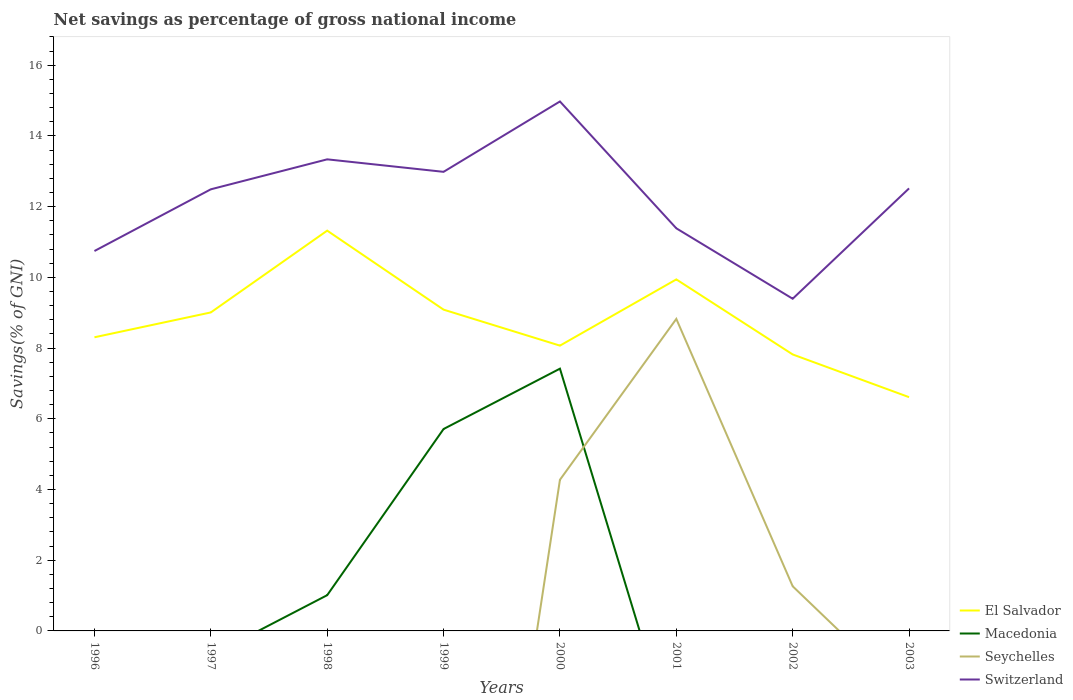Does the line corresponding to El Salvador intersect with the line corresponding to Seychelles?
Keep it short and to the point. No. Is the number of lines equal to the number of legend labels?
Your answer should be compact. No. What is the total total savings in El Salvador in the graph?
Your answer should be very brief. 0.24. What is the difference between the highest and the second highest total savings in Seychelles?
Ensure brevity in your answer.  8.82. How many lines are there?
Your response must be concise. 4. What is the difference between two consecutive major ticks on the Y-axis?
Provide a short and direct response. 2. Are the values on the major ticks of Y-axis written in scientific E-notation?
Make the answer very short. No. Does the graph contain any zero values?
Offer a very short reply. Yes. Does the graph contain grids?
Offer a terse response. No. How are the legend labels stacked?
Provide a succinct answer. Vertical. What is the title of the graph?
Offer a terse response. Net savings as percentage of gross national income. What is the label or title of the Y-axis?
Your response must be concise. Savings(% of GNI). What is the Savings(% of GNI) in El Salvador in 1996?
Provide a short and direct response. 8.3. What is the Savings(% of GNI) of Switzerland in 1996?
Your answer should be very brief. 10.74. What is the Savings(% of GNI) of El Salvador in 1997?
Ensure brevity in your answer.  9.01. What is the Savings(% of GNI) of Macedonia in 1997?
Provide a succinct answer. 0. What is the Savings(% of GNI) of Seychelles in 1997?
Give a very brief answer. 0. What is the Savings(% of GNI) of Switzerland in 1997?
Provide a short and direct response. 12.49. What is the Savings(% of GNI) of El Salvador in 1998?
Offer a terse response. 11.32. What is the Savings(% of GNI) of Macedonia in 1998?
Your response must be concise. 1.01. What is the Savings(% of GNI) of Switzerland in 1998?
Ensure brevity in your answer.  13.34. What is the Savings(% of GNI) in El Salvador in 1999?
Offer a terse response. 9.09. What is the Savings(% of GNI) in Macedonia in 1999?
Keep it short and to the point. 5.71. What is the Savings(% of GNI) in Seychelles in 1999?
Make the answer very short. 0. What is the Savings(% of GNI) of Switzerland in 1999?
Offer a very short reply. 12.98. What is the Savings(% of GNI) of El Salvador in 2000?
Your response must be concise. 8.07. What is the Savings(% of GNI) of Macedonia in 2000?
Keep it short and to the point. 7.42. What is the Savings(% of GNI) in Seychelles in 2000?
Keep it short and to the point. 4.27. What is the Savings(% of GNI) of Switzerland in 2000?
Your response must be concise. 14.97. What is the Savings(% of GNI) of El Salvador in 2001?
Give a very brief answer. 9.94. What is the Savings(% of GNI) in Macedonia in 2001?
Your answer should be very brief. 0. What is the Savings(% of GNI) in Seychelles in 2001?
Offer a terse response. 8.82. What is the Savings(% of GNI) of Switzerland in 2001?
Your response must be concise. 11.39. What is the Savings(% of GNI) in El Salvador in 2002?
Your answer should be compact. 7.82. What is the Savings(% of GNI) in Macedonia in 2002?
Your answer should be very brief. 0. What is the Savings(% of GNI) of Seychelles in 2002?
Give a very brief answer. 1.26. What is the Savings(% of GNI) in Switzerland in 2002?
Provide a short and direct response. 9.39. What is the Savings(% of GNI) of El Salvador in 2003?
Provide a short and direct response. 6.61. What is the Savings(% of GNI) of Macedonia in 2003?
Offer a very short reply. 0. What is the Savings(% of GNI) of Switzerland in 2003?
Your answer should be very brief. 12.51. Across all years, what is the maximum Savings(% of GNI) of El Salvador?
Make the answer very short. 11.32. Across all years, what is the maximum Savings(% of GNI) of Macedonia?
Your answer should be very brief. 7.42. Across all years, what is the maximum Savings(% of GNI) in Seychelles?
Keep it short and to the point. 8.82. Across all years, what is the maximum Savings(% of GNI) in Switzerland?
Your answer should be very brief. 14.97. Across all years, what is the minimum Savings(% of GNI) of El Salvador?
Give a very brief answer. 6.61. Across all years, what is the minimum Savings(% of GNI) in Macedonia?
Provide a succinct answer. 0. Across all years, what is the minimum Savings(% of GNI) in Switzerland?
Give a very brief answer. 9.39. What is the total Savings(% of GNI) in El Salvador in the graph?
Offer a terse response. 70.16. What is the total Savings(% of GNI) of Macedonia in the graph?
Offer a terse response. 14.14. What is the total Savings(% of GNI) of Seychelles in the graph?
Ensure brevity in your answer.  14.36. What is the total Savings(% of GNI) in Switzerland in the graph?
Provide a succinct answer. 97.82. What is the difference between the Savings(% of GNI) of El Salvador in 1996 and that in 1997?
Your answer should be compact. -0.7. What is the difference between the Savings(% of GNI) of Switzerland in 1996 and that in 1997?
Provide a succinct answer. -1.75. What is the difference between the Savings(% of GNI) of El Salvador in 1996 and that in 1998?
Offer a terse response. -3.02. What is the difference between the Savings(% of GNI) of Switzerland in 1996 and that in 1998?
Make the answer very short. -2.59. What is the difference between the Savings(% of GNI) of El Salvador in 1996 and that in 1999?
Your answer should be very brief. -0.78. What is the difference between the Savings(% of GNI) in Switzerland in 1996 and that in 1999?
Provide a short and direct response. -2.24. What is the difference between the Savings(% of GNI) in El Salvador in 1996 and that in 2000?
Offer a very short reply. 0.24. What is the difference between the Savings(% of GNI) in Switzerland in 1996 and that in 2000?
Provide a succinct answer. -4.23. What is the difference between the Savings(% of GNI) of El Salvador in 1996 and that in 2001?
Your answer should be very brief. -1.64. What is the difference between the Savings(% of GNI) of Switzerland in 1996 and that in 2001?
Keep it short and to the point. -0.64. What is the difference between the Savings(% of GNI) in El Salvador in 1996 and that in 2002?
Your response must be concise. 0.49. What is the difference between the Savings(% of GNI) of Switzerland in 1996 and that in 2002?
Your answer should be compact. 1.35. What is the difference between the Savings(% of GNI) of El Salvador in 1996 and that in 2003?
Your response must be concise. 1.69. What is the difference between the Savings(% of GNI) in Switzerland in 1996 and that in 2003?
Ensure brevity in your answer.  -1.77. What is the difference between the Savings(% of GNI) of El Salvador in 1997 and that in 1998?
Make the answer very short. -2.31. What is the difference between the Savings(% of GNI) of Switzerland in 1997 and that in 1998?
Your answer should be very brief. -0.85. What is the difference between the Savings(% of GNI) in El Salvador in 1997 and that in 1999?
Keep it short and to the point. -0.08. What is the difference between the Savings(% of GNI) in Switzerland in 1997 and that in 1999?
Your answer should be very brief. -0.49. What is the difference between the Savings(% of GNI) of El Salvador in 1997 and that in 2000?
Ensure brevity in your answer.  0.94. What is the difference between the Savings(% of GNI) in Switzerland in 1997 and that in 2000?
Your answer should be compact. -2.48. What is the difference between the Savings(% of GNI) of El Salvador in 1997 and that in 2001?
Make the answer very short. -0.93. What is the difference between the Savings(% of GNI) of Switzerland in 1997 and that in 2001?
Your answer should be very brief. 1.1. What is the difference between the Savings(% of GNI) in El Salvador in 1997 and that in 2002?
Offer a very short reply. 1.19. What is the difference between the Savings(% of GNI) of Switzerland in 1997 and that in 2002?
Keep it short and to the point. 3.09. What is the difference between the Savings(% of GNI) of El Salvador in 1997 and that in 2003?
Give a very brief answer. 2.4. What is the difference between the Savings(% of GNI) in Switzerland in 1997 and that in 2003?
Your answer should be very brief. -0.03. What is the difference between the Savings(% of GNI) in El Salvador in 1998 and that in 1999?
Offer a very short reply. 2.23. What is the difference between the Savings(% of GNI) in Macedonia in 1998 and that in 1999?
Your response must be concise. -4.7. What is the difference between the Savings(% of GNI) in Switzerland in 1998 and that in 1999?
Give a very brief answer. 0.35. What is the difference between the Savings(% of GNI) of El Salvador in 1998 and that in 2000?
Provide a short and direct response. 3.25. What is the difference between the Savings(% of GNI) in Macedonia in 1998 and that in 2000?
Ensure brevity in your answer.  -6.41. What is the difference between the Savings(% of GNI) of Switzerland in 1998 and that in 2000?
Offer a very short reply. -1.64. What is the difference between the Savings(% of GNI) of El Salvador in 1998 and that in 2001?
Give a very brief answer. 1.38. What is the difference between the Savings(% of GNI) in Switzerland in 1998 and that in 2001?
Your answer should be compact. 1.95. What is the difference between the Savings(% of GNI) in El Salvador in 1998 and that in 2002?
Offer a very short reply. 3.5. What is the difference between the Savings(% of GNI) in Switzerland in 1998 and that in 2002?
Ensure brevity in your answer.  3.94. What is the difference between the Savings(% of GNI) in El Salvador in 1998 and that in 2003?
Make the answer very short. 4.71. What is the difference between the Savings(% of GNI) of Switzerland in 1998 and that in 2003?
Your answer should be very brief. 0.82. What is the difference between the Savings(% of GNI) in El Salvador in 1999 and that in 2000?
Keep it short and to the point. 1.02. What is the difference between the Savings(% of GNI) in Macedonia in 1999 and that in 2000?
Your answer should be compact. -1.71. What is the difference between the Savings(% of GNI) in Switzerland in 1999 and that in 2000?
Offer a very short reply. -1.99. What is the difference between the Savings(% of GNI) in El Salvador in 1999 and that in 2001?
Provide a succinct answer. -0.86. What is the difference between the Savings(% of GNI) in Switzerland in 1999 and that in 2001?
Ensure brevity in your answer.  1.6. What is the difference between the Savings(% of GNI) of El Salvador in 1999 and that in 2002?
Offer a terse response. 1.27. What is the difference between the Savings(% of GNI) of Switzerland in 1999 and that in 2002?
Provide a succinct answer. 3.59. What is the difference between the Savings(% of GNI) in El Salvador in 1999 and that in 2003?
Provide a succinct answer. 2.48. What is the difference between the Savings(% of GNI) of Switzerland in 1999 and that in 2003?
Keep it short and to the point. 0.47. What is the difference between the Savings(% of GNI) in El Salvador in 2000 and that in 2001?
Give a very brief answer. -1.87. What is the difference between the Savings(% of GNI) in Seychelles in 2000 and that in 2001?
Offer a very short reply. -4.55. What is the difference between the Savings(% of GNI) in Switzerland in 2000 and that in 2001?
Offer a very short reply. 3.59. What is the difference between the Savings(% of GNI) of El Salvador in 2000 and that in 2002?
Your answer should be compact. 0.25. What is the difference between the Savings(% of GNI) of Seychelles in 2000 and that in 2002?
Your answer should be very brief. 3.01. What is the difference between the Savings(% of GNI) of Switzerland in 2000 and that in 2002?
Give a very brief answer. 5.58. What is the difference between the Savings(% of GNI) of El Salvador in 2000 and that in 2003?
Give a very brief answer. 1.46. What is the difference between the Savings(% of GNI) of Switzerland in 2000 and that in 2003?
Give a very brief answer. 2.46. What is the difference between the Savings(% of GNI) of El Salvador in 2001 and that in 2002?
Your answer should be compact. 2.12. What is the difference between the Savings(% of GNI) in Seychelles in 2001 and that in 2002?
Offer a terse response. 7.56. What is the difference between the Savings(% of GNI) in Switzerland in 2001 and that in 2002?
Your response must be concise. 1.99. What is the difference between the Savings(% of GNI) of El Salvador in 2001 and that in 2003?
Ensure brevity in your answer.  3.33. What is the difference between the Savings(% of GNI) of Switzerland in 2001 and that in 2003?
Provide a short and direct response. -1.13. What is the difference between the Savings(% of GNI) of El Salvador in 2002 and that in 2003?
Give a very brief answer. 1.21. What is the difference between the Savings(% of GNI) in Switzerland in 2002 and that in 2003?
Offer a very short reply. -3.12. What is the difference between the Savings(% of GNI) in El Salvador in 1996 and the Savings(% of GNI) in Switzerland in 1997?
Ensure brevity in your answer.  -4.18. What is the difference between the Savings(% of GNI) of El Salvador in 1996 and the Savings(% of GNI) of Macedonia in 1998?
Provide a succinct answer. 7.29. What is the difference between the Savings(% of GNI) in El Salvador in 1996 and the Savings(% of GNI) in Switzerland in 1998?
Make the answer very short. -5.03. What is the difference between the Savings(% of GNI) of El Salvador in 1996 and the Savings(% of GNI) of Macedonia in 1999?
Your answer should be compact. 2.59. What is the difference between the Savings(% of GNI) in El Salvador in 1996 and the Savings(% of GNI) in Switzerland in 1999?
Make the answer very short. -4.68. What is the difference between the Savings(% of GNI) of El Salvador in 1996 and the Savings(% of GNI) of Macedonia in 2000?
Offer a terse response. 0.89. What is the difference between the Savings(% of GNI) of El Salvador in 1996 and the Savings(% of GNI) of Seychelles in 2000?
Keep it short and to the point. 4.03. What is the difference between the Savings(% of GNI) in El Salvador in 1996 and the Savings(% of GNI) in Switzerland in 2000?
Ensure brevity in your answer.  -6.67. What is the difference between the Savings(% of GNI) in El Salvador in 1996 and the Savings(% of GNI) in Seychelles in 2001?
Your answer should be very brief. -0.52. What is the difference between the Savings(% of GNI) of El Salvador in 1996 and the Savings(% of GNI) of Switzerland in 2001?
Your response must be concise. -3.08. What is the difference between the Savings(% of GNI) in El Salvador in 1996 and the Savings(% of GNI) in Seychelles in 2002?
Your answer should be very brief. 7.04. What is the difference between the Savings(% of GNI) of El Salvador in 1996 and the Savings(% of GNI) of Switzerland in 2002?
Offer a very short reply. -1.09. What is the difference between the Savings(% of GNI) in El Salvador in 1996 and the Savings(% of GNI) in Switzerland in 2003?
Your answer should be very brief. -4.21. What is the difference between the Savings(% of GNI) of El Salvador in 1997 and the Savings(% of GNI) of Macedonia in 1998?
Provide a succinct answer. 8. What is the difference between the Savings(% of GNI) of El Salvador in 1997 and the Savings(% of GNI) of Switzerland in 1998?
Your answer should be very brief. -4.33. What is the difference between the Savings(% of GNI) in El Salvador in 1997 and the Savings(% of GNI) in Macedonia in 1999?
Provide a succinct answer. 3.3. What is the difference between the Savings(% of GNI) of El Salvador in 1997 and the Savings(% of GNI) of Switzerland in 1999?
Your response must be concise. -3.98. What is the difference between the Savings(% of GNI) of El Salvador in 1997 and the Savings(% of GNI) of Macedonia in 2000?
Ensure brevity in your answer.  1.59. What is the difference between the Savings(% of GNI) in El Salvador in 1997 and the Savings(% of GNI) in Seychelles in 2000?
Ensure brevity in your answer.  4.73. What is the difference between the Savings(% of GNI) of El Salvador in 1997 and the Savings(% of GNI) of Switzerland in 2000?
Your response must be concise. -5.97. What is the difference between the Savings(% of GNI) in El Salvador in 1997 and the Savings(% of GNI) in Seychelles in 2001?
Your answer should be very brief. 0.18. What is the difference between the Savings(% of GNI) in El Salvador in 1997 and the Savings(% of GNI) in Switzerland in 2001?
Your answer should be compact. -2.38. What is the difference between the Savings(% of GNI) in El Salvador in 1997 and the Savings(% of GNI) in Seychelles in 2002?
Give a very brief answer. 7.74. What is the difference between the Savings(% of GNI) of El Salvador in 1997 and the Savings(% of GNI) of Switzerland in 2002?
Offer a very short reply. -0.39. What is the difference between the Savings(% of GNI) of El Salvador in 1997 and the Savings(% of GNI) of Switzerland in 2003?
Your answer should be very brief. -3.51. What is the difference between the Savings(% of GNI) in El Salvador in 1998 and the Savings(% of GNI) in Macedonia in 1999?
Offer a very short reply. 5.61. What is the difference between the Savings(% of GNI) in El Salvador in 1998 and the Savings(% of GNI) in Switzerland in 1999?
Your answer should be compact. -1.66. What is the difference between the Savings(% of GNI) of Macedonia in 1998 and the Savings(% of GNI) of Switzerland in 1999?
Offer a very short reply. -11.97. What is the difference between the Savings(% of GNI) in El Salvador in 1998 and the Savings(% of GNI) in Macedonia in 2000?
Keep it short and to the point. 3.9. What is the difference between the Savings(% of GNI) in El Salvador in 1998 and the Savings(% of GNI) in Seychelles in 2000?
Offer a very short reply. 7.05. What is the difference between the Savings(% of GNI) of El Salvador in 1998 and the Savings(% of GNI) of Switzerland in 2000?
Offer a very short reply. -3.65. What is the difference between the Savings(% of GNI) in Macedonia in 1998 and the Savings(% of GNI) in Seychelles in 2000?
Offer a terse response. -3.26. What is the difference between the Savings(% of GNI) in Macedonia in 1998 and the Savings(% of GNI) in Switzerland in 2000?
Your answer should be very brief. -13.96. What is the difference between the Savings(% of GNI) of El Salvador in 1998 and the Savings(% of GNI) of Seychelles in 2001?
Your response must be concise. 2.5. What is the difference between the Savings(% of GNI) of El Salvador in 1998 and the Savings(% of GNI) of Switzerland in 2001?
Your response must be concise. -0.07. What is the difference between the Savings(% of GNI) in Macedonia in 1998 and the Savings(% of GNI) in Seychelles in 2001?
Give a very brief answer. -7.81. What is the difference between the Savings(% of GNI) in Macedonia in 1998 and the Savings(% of GNI) in Switzerland in 2001?
Keep it short and to the point. -10.37. What is the difference between the Savings(% of GNI) in El Salvador in 1998 and the Savings(% of GNI) in Seychelles in 2002?
Provide a succinct answer. 10.06. What is the difference between the Savings(% of GNI) of El Salvador in 1998 and the Savings(% of GNI) of Switzerland in 2002?
Ensure brevity in your answer.  1.93. What is the difference between the Savings(% of GNI) in Macedonia in 1998 and the Savings(% of GNI) in Seychelles in 2002?
Keep it short and to the point. -0.25. What is the difference between the Savings(% of GNI) of Macedonia in 1998 and the Savings(% of GNI) of Switzerland in 2002?
Ensure brevity in your answer.  -8.38. What is the difference between the Savings(% of GNI) of El Salvador in 1998 and the Savings(% of GNI) of Switzerland in 2003?
Your answer should be compact. -1.19. What is the difference between the Savings(% of GNI) in Macedonia in 1998 and the Savings(% of GNI) in Switzerland in 2003?
Your response must be concise. -11.5. What is the difference between the Savings(% of GNI) of El Salvador in 1999 and the Savings(% of GNI) of Macedonia in 2000?
Offer a terse response. 1.67. What is the difference between the Savings(% of GNI) of El Salvador in 1999 and the Savings(% of GNI) of Seychelles in 2000?
Your response must be concise. 4.81. What is the difference between the Savings(% of GNI) of El Salvador in 1999 and the Savings(% of GNI) of Switzerland in 2000?
Offer a terse response. -5.89. What is the difference between the Savings(% of GNI) of Macedonia in 1999 and the Savings(% of GNI) of Seychelles in 2000?
Your answer should be very brief. 1.44. What is the difference between the Savings(% of GNI) of Macedonia in 1999 and the Savings(% of GNI) of Switzerland in 2000?
Your response must be concise. -9.26. What is the difference between the Savings(% of GNI) of El Salvador in 1999 and the Savings(% of GNI) of Seychelles in 2001?
Keep it short and to the point. 0.26. What is the difference between the Savings(% of GNI) in El Salvador in 1999 and the Savings(% of GNI) in Switzerland in 2001?
Ensure brevity in your answer.  -2.3. What is the difference between the Savings(% of GNI) in Macedonia in 1999 and the Savings(% of GNI) in Seychelles in 2001?
Provide a succinct answer. -3.11. What is the difference between the Savings(% of GNI) in Macedonia in 1999 and the Savings(% of GNI) in Switzerland in 2001?
Provide a succinct answer. -5.68. What is the difference between the Savings(% of GNI) of El Salvador in 1999 and the Savings(% of GNI) of Seychelles in 2002?
Give a very brief answer. 7.82. What is the difference between the Savings(% of GNI) in El Salvador in 1999 and the Savings(% of GNI) in Switzerland in 2002?
Keep it short and to the point. -0.31. What is the difference between the Savings(% of GNI) of Macedonia in 1999 and the Savings(% of GNI) of Seychelles in 2002?
Your response must be concise. 4.45. What is the difference between the Savings(% of GNI) in Macedonia in 1999 and the Savings(% of GNI) in Switzerland in 2002?
Ensure brevity in your answer.  -3.68. What is the difference between the Savings(% of GNI) of El Salvador in 1999 and the Savings(% of GNI) of Switzerland in 2003?
Give a very brief answer. -3.43. What is the difference between the Savings(% of GNI) in Macedonia in 1999 and the Savings(% of GNI) in Switzerland in 2003?
Provide a succinct answer. -6.81. What is the difference between the Savings(% of GNI) in El Salvador in 2000 and the Savings(% of GNI) in Seychelles in 2001?
Provide a short and direct response. -0.76. What is the difference between the Savings(% of GNI) in El Salvador in 2000 and the Savings(% of GNI) in Switzerland in 2001?
Provide a short and direct response. -3.32. What is the difference between the Savings(% of GNI) in Macedonia in 2000 and the Savings(% of GNI) in Seychelles in 2001?
Provide a short and direct response. -1.41. What is the difference between the Savings(% of GNI) of Macedonia in 2000 and the Savings(% of GNI) of Switzerland in 2001?
Give a very brief answer. -3.97. What is the difference between the Savings(% of GNI) of Seychelles in 2000 and the Savings(% of GNI) of Switzerland in 2001?
Offer a very short reply. -7.11. What is the difference between the Savings(% of GNI) of El Salvador in 2000 and the Savings(% of GNI) of Seychelles in 2002?
Give a very brief answer. 6.81. What is the difference between the Savings(% of GNI) in El Salvador in 2000 and the Savings(% of GNI) in Switzerland in 2002?
Provide a succinct answer. -1.33. What is the difference between the Savings(% of GNI) in Macedonia in 2000 and the Savings(% of GNI) in Seychelles in 2002?
Provide a short and direct response. 6.15. What is the difference between the Savings(% of GNI) in Macedonia in 2000 and the Savings(% of GNI) in Switzerland in 2002?
Offer a terse response. -1.98. What is the difference between the Savings(% of GNI) of Seychelles in 2000 and the Savings(% of GNI) of Switzerland in 2002?
Offer a very short reply. -5.12. What is the difference between the Savings(% of GNI) of El Salvador in 2000 and the Savings(% of GNI) of Switzerland in 2003?
Offer a terse response. -4.45. What is the difference between the Savings(% of GNI) of Macedonia in 2000 and the Savings(% of GNI) of Switzerland in 2003?
Make the answer very short. -5.1. What is the difference between the Savings(% of GNI) of Seychelles in 2000 and the Savings(% of GNI) of Switzerland in 2003?
Ensure brevity in your answer.  -8.24. What is the difference between the Savings(% of GNI) in El Salvador in 2001 and the Savings(% of GNI) in Seychelles in 2002?
Keep it short and to the point. 8.68. What is the difference between the Savings(% of GNI) of El Salvador in 2001 and the Savings(% of GNI) of Switzerland in 2002?
Provide a short and direct response. 0.55. What is the difference between the Savings(% of GNI) of Seychelles in 2001 and the Savings(% of GNI) of Switzerland in 2002?
Give a very brief answer. -0.57. What is the difference between the Savings(% of GNI) in El Salvador in 2001 and the Savings(% of GNI) in Switzerland in 2003?
Make the answer very short. -2.57. What is the difference between the Savings(% of GNI) of Seychelles in 2001 and the Savings(% of GNI) of Switzerland in 2003?
Your answer should be very brief. -3.69. What is the difference between the Savings(% of GNI) of El Salvador in 2002 and the Savings(% of GNI) of Switzerland in 2003?
Your answer should be very brief. -4.7. What is the difference between the Savings(% of GNI) of Seychelles in 2002 and the Savings(% of GNI) of Switzerland in 2003?
Give a very brief answer. -11.25. What is the average Savings(% of GNI) in El Salvador per year?
Keep it short and to the point. 8.77. What is the average Savings(% of GNI) of Macedonia per year?
Your answer should be compact. 1.77. What is the average Savings(% of GNI) in Seychelles per year?
Provide a succinct answer. 1.79. What is the average Savings(% of GNI) of Switzerland per year?
Provide a succinct answer. 12.23. In the year 1996, what is the difference between the Savings(% of GNI) in El Salvador and Savings(% of GNI) in Switzerland?
Provide a succinct answer. -2.44. In the year 1997, what is the difference between the Savings(% of GNI) of El Salvador and Savings(% of GNI) of Switzerland?
Your response must be concise. -3.48. In the year 1998, what is the difference between the Savings(% of GNI) in El Salvador and Savings(% of GNI) in Macedonia?
Your answer should be very brief. 10.31. In the year 1998, what is the difference between the Savings(% of GNI) of El Salvador and Savings(% of GNI) of Switzerland?
Your answer should be compact. -2.02. In the year 1998, what is the difference between the Savings(% of GNI) of Macedonia and Savings(% of GNI) of Switzerland?
Your answer should be very brief. -12.33. In the year 1999, what is the difference between the Savings(% of GNI) of El Salvador and Savings(% of GNI) of Macedonia?
Your answer should be very brief. 3.38. In the year 1999, what is the difference between the Savings(% of GNI) of El Salvador and Savings(% of GNI) of Switzerland?
Offer a terse response. -3.9. In the year 1999, what is the difference between the Savings(% of GNI) of Macedonia and Savings(% of GNI) of Switzerland?
Your answer should be very brief. -7.27. In the year 2000, what is the difference between the Savings(% of GNI) of El Salvador and Savings(% of GNI) of Macedonia?
Your answer should be very brief. 0.65. In the year 2000, what is the difference between the Savings(% of GNI) in El Salvador and Savings(% of GNI) in Seychelles?
Offer a very short reply. 3.79. In the year 2000, what is the difference between the Savings(% of GNI) in El Salvador and Savings(% of GNI) in Switzerland?
Offer a very short reply. -6.9. In the year 2000, what is the difference between the Savings(% of GNI) in Macedonia and Savings(% of GNI) in Seychelles?
Your answer should be very brief. 3.14. In the year 2000, what is the difference between the Savings(% of GNI) in Macedonia and Savings(% of GNI) in Switzerland?
Make the answer very short. -7.56. In the year 2000, what is the difference between the Savings(% of GNI) in Seychelles and Savings(% of GNI) in Switzerland?
Your response must be concise. -10.7. In the year 2001, what is the difference between the Savings(% of GNI) of El Salvador and Savings(% of GNI) of Seychelles?
Your answer should be very brief. 1.12. In the year 2001, what is the difference between the Savings(% of GNI) in El Salvador and Savings(% of GNI) in Switzerland?
Your answer should be very brief. -1.44. In the year 2001, what is the difference between the Savings(% of GNI) in Seychelles and Savings(% of GNI) in Switzerland?
Your response must be concise. -2.56. In the year 2002, what is the difference between the Savings(% of GNI) in El Salvador and Savings(% of GNI) in Seychelles?
Your response must be concise. 6.56. In the year 2002, what is the difference between the Savings(% of GNI) of El Salvador and Savings(% of GNI) of Switzerland?
Offer a very short reply. -1.58. In the year 2002, what is the difference between the Savings(% of GNI) of Seychelles and Savings(% of GNI) of Switzerland?
Give a very brief answer. -8.13. In the year 2003, what is the difference between the Savings(% of GNI) in El Salvador and Savings(% of GNI) in Switzerland?
Your answer should be very brief. -5.9. What is the ratio of the Savings(% of GNI) of El Salvador in 1996 to that in 1997?
Keep it short and to the point. 0.92. What is the ratio of the Savings(% of GNI) of Switzerland in 1996 to that in 1997?
Provide a succinct answer. 0.86. What is the ratio of the Savings(% of GNI) of El Salvador in 1996 to that in 1998?
Make the answer very short. 0.73. What is the ratio of the Savings(% of GNI) in Switzerland in 1996 to that in 1998?
Keep it short and to the point. 0.81. What is the ratio of the Savings(% of GNI) in El Salvador in 1996 to that in 1999?
Make the answer very short. 0.91. What is the ratio of the Savings(% of GNI) of Switzerland in 1996 to that in 1999?
Provide a succinct answer. 0.83. What is the ratio of the Savings(% of GNI) in El Salvador in 1996 to that in 2000?
Your response must be concise. 1.03. What is the ratio of the Savings(% of GNI) of Switzerland in 1996 to that in 2000?
Make the answer very short. 0.72. What is the ratio of the Savings(% of GNI) of El Salvador in 1996 to that in 2001?
Offer a terse response. 0.84. What is the ratio of the Savings(% of GNI) of Switzerland in 1996 to that in 2001?
Your answer should be compact. 0.94. What is the ratio of the Savings(% of GNI) of El Salvador in 1996 to that in 2002?
Keep it short and to the point. 1.06. What is the ratio of the Savings(% of GNI) in Switzerland in 1996 to that in 2002?
Offer a terse response. 1.14. What is the ratio of the Savings(% of GNI) of El Salvador in 1996 to that in 2003?
Give a very brief answer. 1.26. What is the ratio of the Savings(% of GNI) in Switzerland in 1996 to that in 2003?
Keep it short and to the point. 0.86. What is the ratio of the Savings(% of GNI) in El Salvador in 1997 to that in 1998?
Give a very brief answer. 0.8. What is the ratio of the Savings(% of GNI) of Switzerland in 1997 to that in 1998?
Your answer should be compact. 0.94. What is the ratio of the Savings(% of GNI) of El Salvador in 1997 to that in 1999?
Ensure brevity in your answer.  0.99. What is the ratio of the Savings(% of GNI) of Switzerland in 1997 to that in 1999?
Your answer should be very brief. 0.96. What is the ratio of the Savings(% of GNI) in El Salvador in 1997 to that in 2000?
Your answer should be compact. 1.12. What is the ratio of the Savings(% of GNI) of Switzerland in 1997 to that in 2000?
Offer a terse response. 0.83. What is the ratio of the Savings(% of GNI) of El Salvador in 1997 to that in 2001?
Provide a succinct answer. 0.91. What is the ratio of the Savings(% of GNI) of Switzerland in 1997 to that in 2001?
Offer a terse response. 1.1. What is the ratio of the Savings(% of GNI) of El Salvador in 1997 to that in 2002?
Your response must be concise. 1.15. What is the ratio of the Savings(% of GNI) in Switzerland in 1997 to that in 2002?
Your answer should be compact. 1.33. What is the ratio of the Savings(% of GNI) of El Salvador in 1997 to that in 2003?
Offer a terse response. 1.36. What is the ratio of the Savings(% of GNI) of El Salvador in 1998 to that in 1999?
Provide a succinct answer. 1.25. What is the ratio of the Savings(% of GNI) in Macedonia in 1998 to that in 1999?
Offer a very short reply. 0.18. What is the ratio of the Savings(% of GNI) of Switzerland in 1998 to that in 1999?
Make the answer very short. 1.03. What is the ratio of the Savings(% of GNI) in El Salvador in 1998 to that in 2000?
Your answer should be very brief. 1.4. What is the ratio of the Savings(% of GNI) of Macedonia in 1998 to that in 2000?
Keep it short and to the point. 0.14. What is the ratio of the Savings(% of GNI) of Switzerland in 1998 to that in 2000?
Offer a terse response. 0.89. What is the ratio of the Savings(% of GNI) in El Salvador in 1998 to that in 2001?
Your response must be concise. 1.14. What is the ratio of the Savings(% of GNI) of Switzerland in 1998 to that in 2001?
Provide a short and direct response. 1.17. What is the ratio of the Savings(% of GNI) of El Salvador in 1998 to that in 2002?
Offer a very short reply. 1.45. What is the ratio of the Savings(% of GNI) in Switzerland in 1998 to that in 2002?
Provide a succinct answer. 1.42. What is the ratio of the Savings(% of GNI) of El Salvador in 1998 to that in 2003?
Give a very brief answer. 1.71. What is the ratio of the Savings(% of GNI) of Switzerland in 1998 to that in 2003?
Offer a terse response. 1.07. What is the ratio of the Savings(% of GNI) of El Salvador in 1999 to that in 2000?
Make the answer very short. 1.13. What is the ratio of the Savings(% of GNI) in Macedonia in 1999 to that in 2000?
Provide a succinct answer. 0.77. What is the ratio of the Savings(% of GNI) of Switzerland in 1999 to that in 2000?
Make the answer very short. 0.87. What is the ratio of the Savings(% of GNI) of El Salvador in 1999 to that in 2001?
Your answer should be very brief. 0.91. What is the ratio of the Savings(% of GNI) in Switzerland in 1999 to that in 2001?
Give a very brief answer. 1.14. What is the ratio of the Savings(% of GNI) of El Salvador in 1999 to that in 2002?
Provide a succinct answer. 1.16. What is the ratio of the Savings(% of GNI) in Switzerland in 1999 to that in 2002?
Your response must be concise. 1.38. What is the ratio of the Savings(% of GNI) of El Salvador in 1999 to that in 2003?
Make the answer very short. 1.37. What is the ratio of the Savings(% of GNI) of Switzerland in 1999 to that in 2003?
Your response must be concise. 1.04. What is the ratio of the Savings(% of GNI) of El Salvador in 2000 to that in 2001?
Offer a terse response. 0.81. What is the ratio of the Savings(% of GNI) of Seychelles in 2000 to that in 2001?
Your answer should be compact. 0.48. What is the ratio of the Savings(% of GNI) of Switzerland in 2000 to that in 2001?
Your answer should be very brief. 1.32. What is the ratio of the Savings(% of GNI) of El Salvador in 2000 to that in 2002?
Your answer should be very brief. 1.03. What is the ratio of the Savings(% of GNI) in Seychelles in 2000 to that in 2002?
Offer a very short reply. 3.39. What is the ratio of the Savings(% of GNI) in Switzerland in 2000 to that in 2002?
Keep it short and to the point. 1.59. What is the ratio of the Savings(% of GNI) of El Salvador in 2000 to that in 2003?
Ensure brevity in your answer.  1.22. What is the ratio of the Savings(% of GNI) of Switzerland in 2000 to that in 2003?
Ensure brevity in your answer.  1.2. What is the ratio of the Savings(% of GNI) of El Salvador in 2001 to that in 2002?
Give a very brief answer. 1.27. What is the ratio of the Savings(% of GNI) in Seychelles in 2001 to that in 2002?
Your response must be concise. 6.99. What is the ratio of the Savings(% of GNI) in Switzerland in 2001 to that in 2002?
Your response must be concise. 1.21. What is the ratio of the Savings(% of GNI) of El Salvador in 2001 to that in 2003?
Give a very brief answer. 1.5. What is the ratio of the Savings(% of GNI) of Switzerland in 2001 to that in 2003?
Ensure brevity in your answer.  0.91. What is the ratio of the Savings(% of GNI) of El Salvador in 2002 to that in 2003?
Your answer should be very brief. 1.18. What is the ratio of the Savings(% of GNI) in Switzerland in 2002 to that in 2003?
Your answer should be compact. 0.75. What is the difference between the highest and the second highest Savings(% of GNI) of El Salvador?
Your answer should be very brief. 1.38. What is the difference between the highest and the second highest Savings(% of GNI) in Macedonia?
Your answer should be very brief. 1.71. What is the difference between the highest and the second highest Savings(% of GNI) of Seychelles?
Offer a very short reply. 4.55. What is the difference between the highest and the second highest Savings(% of GNI) of Switzerland?
Give a very brief answer. 1.64. What is the difference between the highest and the lowest Savings(% of GNI) of El Salvador?
Keep it short and to the point. 4.71. What is the difference between the highest and the lowest Savings(% of GNI) in Macedonia?
Your answer should be very brief. 7.42. What is the difference between the highest and the lowest Savings(% of GNI) in Seychelles?
Your answer should be compact. 8.82. What is the difference between the highest and the lowest Savings(% of GNI) in Switzerland?
Keep it short and to the point. 5.58. 